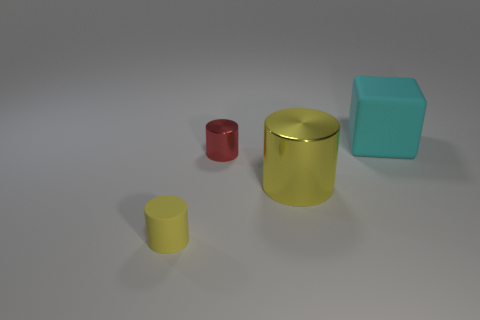What feeling does the composition of the image evoke? The image has a minimalist composition with a clean background and strategically placed colorful objects, evoking a sense of order and simplicity that might be used for a study on color perception or object recognition. 